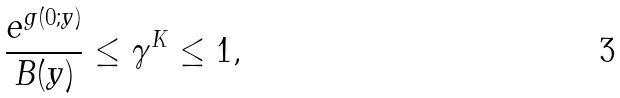Convert formula to latex. <formula><loc_0><loc_0><loc_500><loc_500>\frac { e ^ { g ( 0 ; y ) } } { B ( y ) } \leq \gamma ^ { K } \leq 1 ,</formula> 